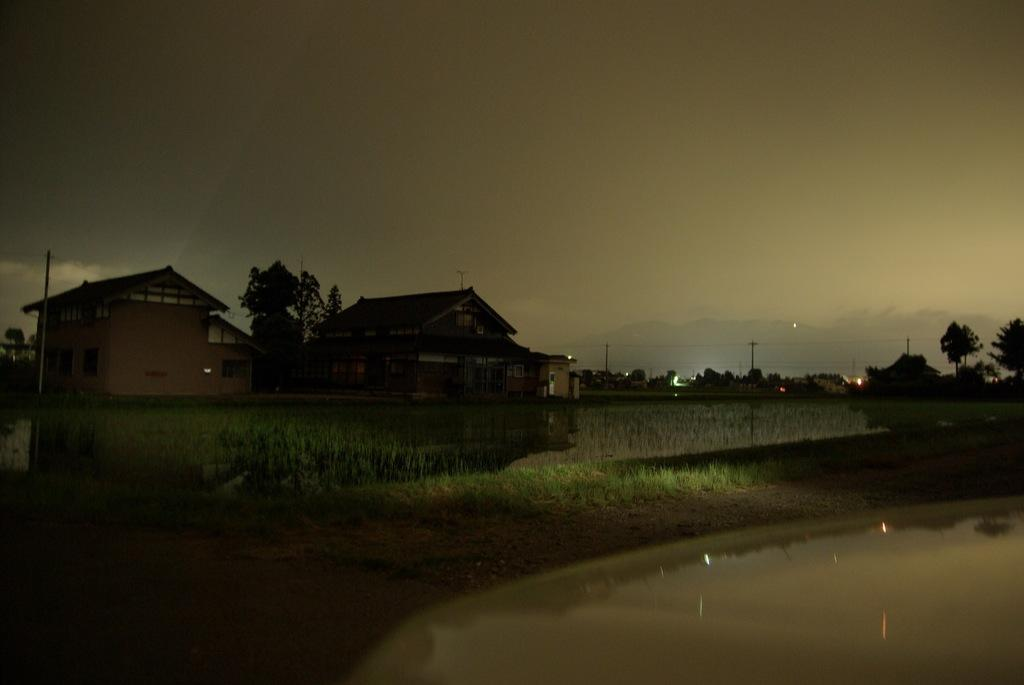What type of structures can be seen in the image? There are houses with roofs in the image. What type of vegetation is visible in the image? There is grass visible in the image. What natural feature can be seen in the image? There is water visible in the image. What type of plants are present in the image? There are trees in the image. What type of infrastructure is present in the image? There are utility poles with wires in the image. What type of illumination is present in the image? There are lights in the image. What type of geographical feature is visible in the image? There are hills visible in the image. What is the condition of the sky in the image? The sky is cloudy in the image. What type of eggnog is being served at the party in the image? There is no party or eggnog present in the image. What type of interest is being discussed in the image? There is no discussion of interest in the image. 